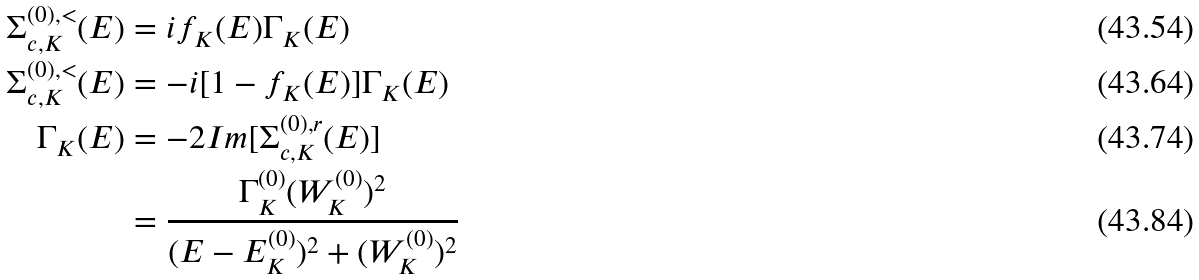<formula> <loc_0><loc_0><loc_500><loc_500>\Sigma _ { c , K } ^ { ( 0 ) , < } ( E ) & = i f _ { K } ( E ) \Gamma _ { K } ( E ) \\ \Sigma _ { c , K } ^ { ( 0 ) , < } ( E ) & = - i [ 1 - f _ { K } ( E ) ] \Gamma _ { K } ( E ) \\ \Gamma _ { K } ( E ) & = - 2 I m [ \Sigma _ { c , K } ^ { ( 0 ) , r } ( E ) ] \\ & = \frac { \Gamma _ { K } ^ { ( 0 ) } ( W _ { K } ^ { ( 0 ) } ) ^ { 2 } } { ( E - E _ { K } ^ { ( 0 ) } ) ^ { 2 } + ( W _ { K } ^ { ( 0 ) } ) ^ { 2 } }</formula> 